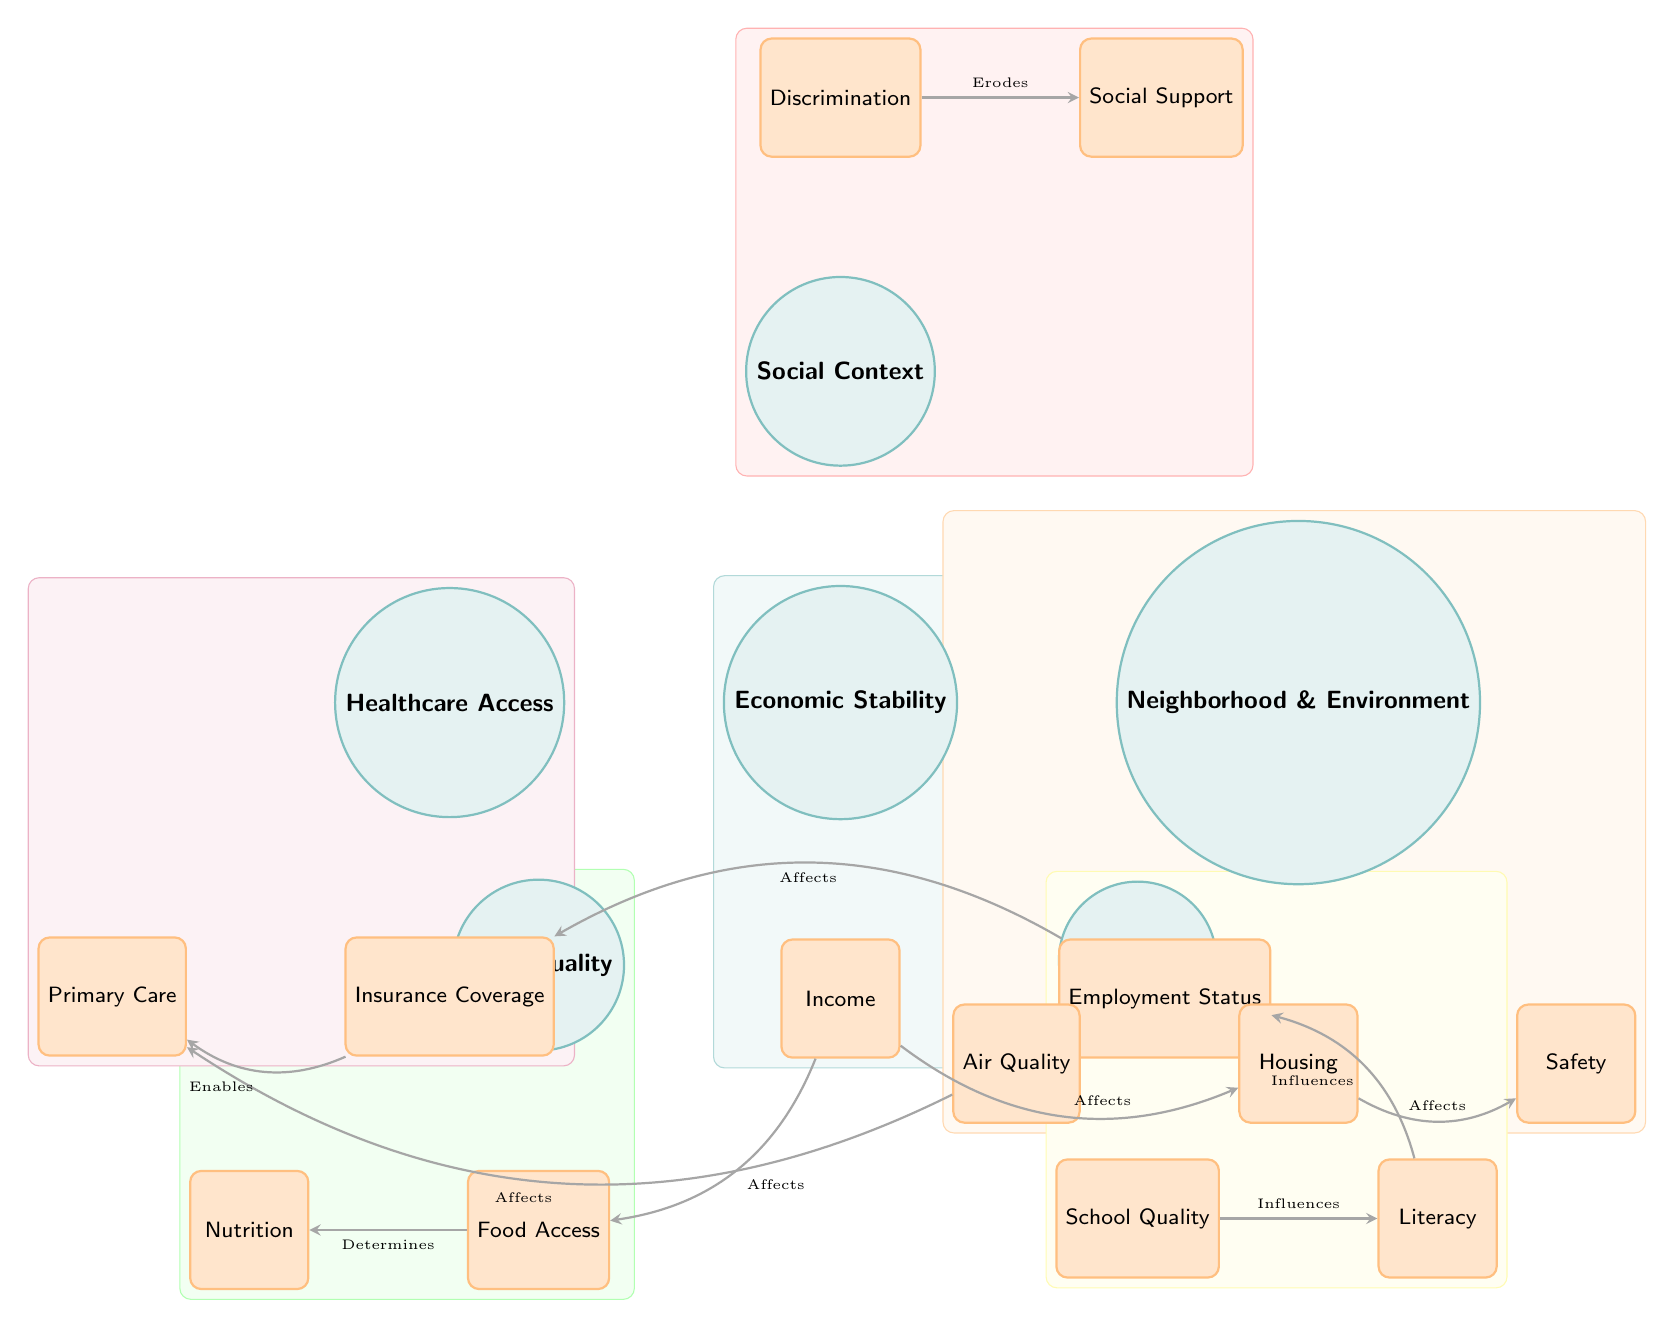What are the main nodes in the diagram? The main nodes are Economic Stability, Neighborhood & Environment, Education, Food Quality, Healthcare Access, and Social Context. Each of these nodes is represented by a circle in the diagram.
Answer: Economic Stability, Neighborhood & Environment, Education, Food Quality, Healthcare Access, Social Context How many sub-nodes are connected to Healthcare Access? The Healthcare Access node has three connected sub-nodes: Insurance Coverage, Primary Care, and one more. We can count these nodes directly from the diagram.
Answer: 2 Which sub-node is connected to the Education node? The sub-nodes connected to Education are School Quality and Literacy. The question is directly looking for a specific sub-node rather than both.
Answer: School Quality What is the relationship between Employment Status and Insurance Coverage? The diagram shows that Employment Status affects Insurance Coverage, meaning there is a direct influence from Employment Status to Insurance Coverage. This can be traced through the directed edge indicating this relationship.
Answer: Affects Which factors overlap in this Venn diagram? The overlapping factors clearly present multiple nodes interacting for overall health impact, indicating a complex relationship among them. The overlapping areas highlight that issues like Economic Stability and Healthcare Access might both relate to racial disparities in health outcomes.
Answer: Economic Stability, Neighborhood & Environment, Education, Food Quality, Healthcare Access, Social Context What effects does Discrimination have according to the diagram? The diagram indicates that Discrimination erodes Social Support, signifying a negative impact on social networks and resources available to individuals from marginalized racial groups.
Answer: Erodes How many edges connect to the Food Quality node? There are two edges directly connected to the Food Quality node, as they show either determining or influencing relationships with its sub-nodes. After checking the connections, counting the edges gives us the answer.
Answer: 2 Which node influences Literacy? The School Quality node influences Literacy according to the directed edge in the diagram, demonstrating the connection between educational quality and reading skills.
Answer: School Quality What does the edge between Air Quality and Primary Care indicate? The edge between Air Quality and Primary Care indicates that Air Quality affects access to Primary Care, which suggests that environmental factors can influence healthcare access.
Answer: Affects 